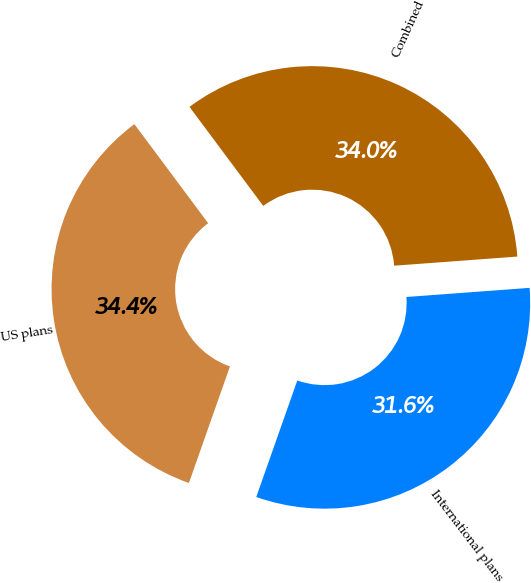Convert chart to OTSL. <chart><loc_0><loc_0><loc_500><loc_500><pie_chart><fcel>US plans<fcel>International plans<fcel>Combined<nl><fcel>34.42%<fcel>31.56%<fcel>34.01%<nl></chart> 